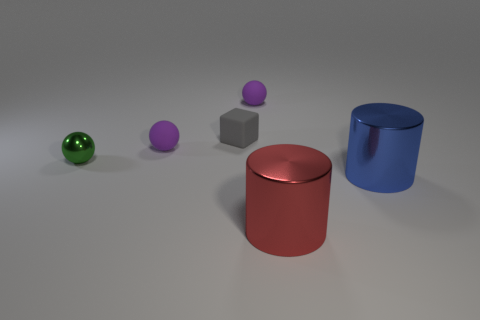Subtract all green cylinders. How many purple balls are left? 2 Add 3 small gray blocks. How many objects exist? 9 Subtract all cylinders. How many objects are left? 4 Subtract 0 yellow cylinders. How many objects are left? 6 Subtract all tiny yellow metallic balls. Subtract all matte things. How many objects are left? 3 Add 4 matte objects. How many matte objects are left? 7 Add 4 green metal balls. How many green metal balls exist? 5 